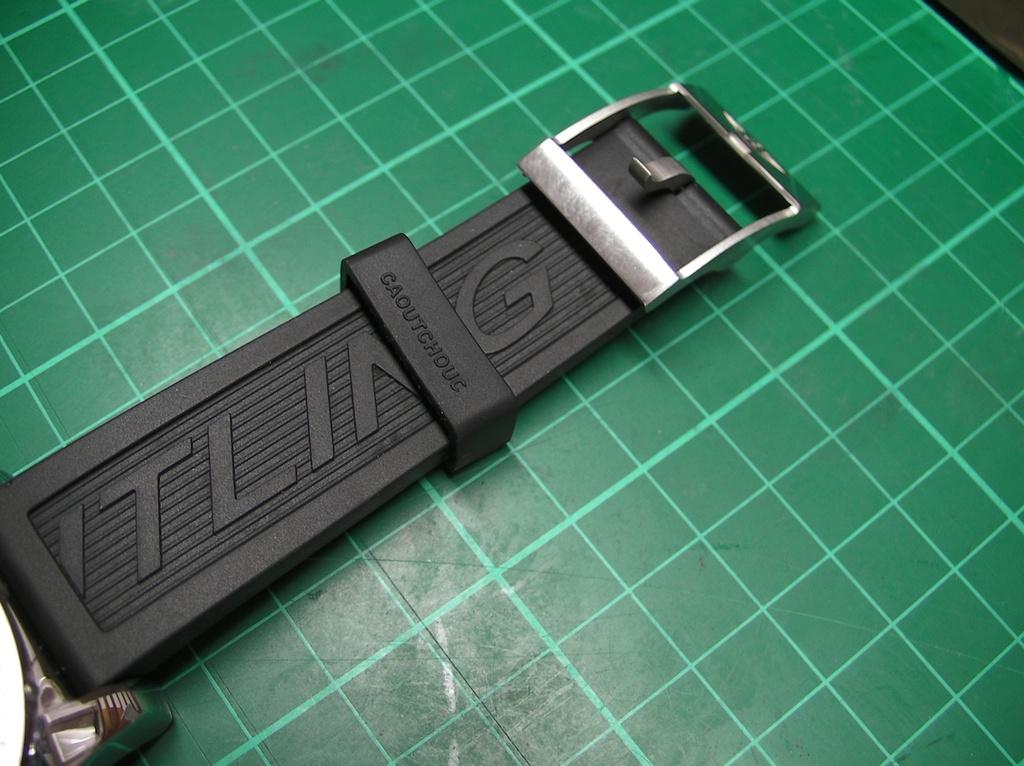What is the name of the material on the rubber wristband?
Ensure brevity in your answer.  Caoutchouc. 